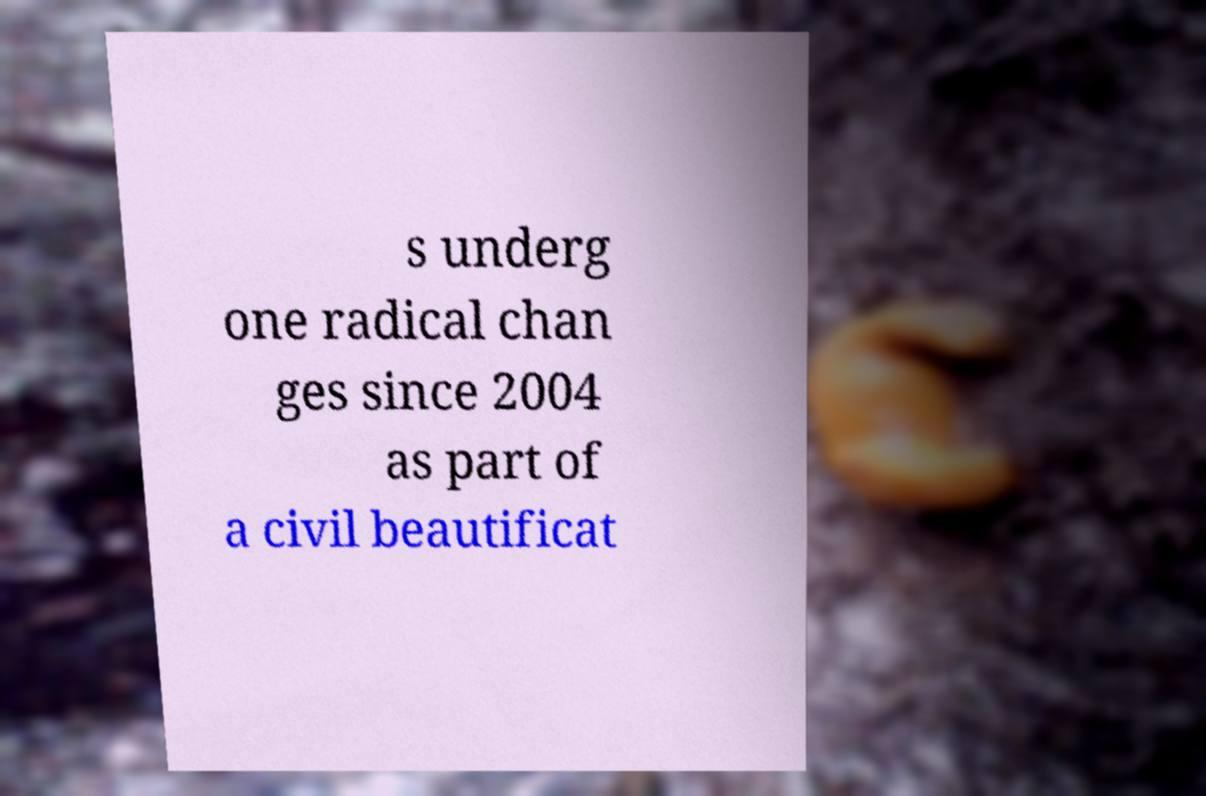Please read and relay the text visible in this image. What does it say? s underg one radical chan ges since 2004 as part of a civil beautificat 